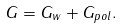Convert formula to latex. <formula><loc_0><loc_0><loc_500><loc_500>G = G _ { w } + G _ { p o l } .</formula> 